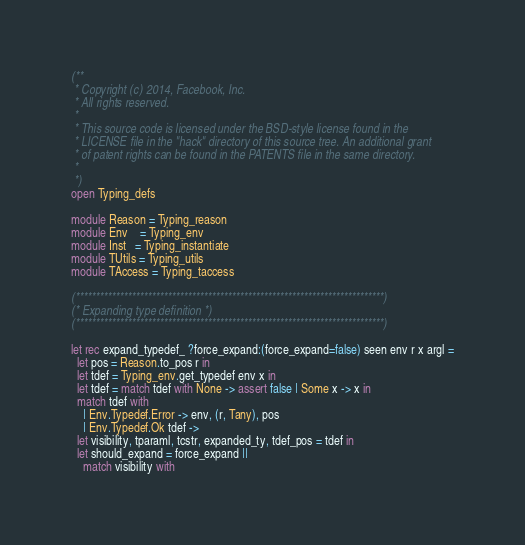<code> <loc_0><loc_0><loc_500><loc_500><_OCaml_>(**
 * Copyright (c) 2014, Facebook, Inc.
 * All rights reserved.
 *
 * This source code is licensed under the BSD-style license found in the
 * LICENSE file in the "hack" directory of this source tree. An additional grant
 * of patent rights can be found in the PATENTS file in the same directory.
 *
 *)
open Typing_defs

module Reason = Typing_reason
module Env    = Typing_env
module Inst   = Typing_instantiate
module TUtils = Typing_utils
module TAccess = Typing_taccess

(*****************************************************************************)
(* Expanding type definition *)
(*****************************************************************************)

let rec expand_typedef_ ?force_expand:(force_expand=false) seen env r x argl =
  let pos = Reason.to_pos r in
  let tdef = Typing_env.get_typedef env x in
  let tdef = match tdef with None -> assert false | Some x -> x in
  match tdef with
    | Env.Typedef.Error -> env, (r, Tany), pos
    | Env.Typedef.Ok tdef ->
  let visibility, tparaml, tcstr, expanded_ty, tdef_pos = tdef in
  let should_expand = force_expand ||
    match visibility with</code> 